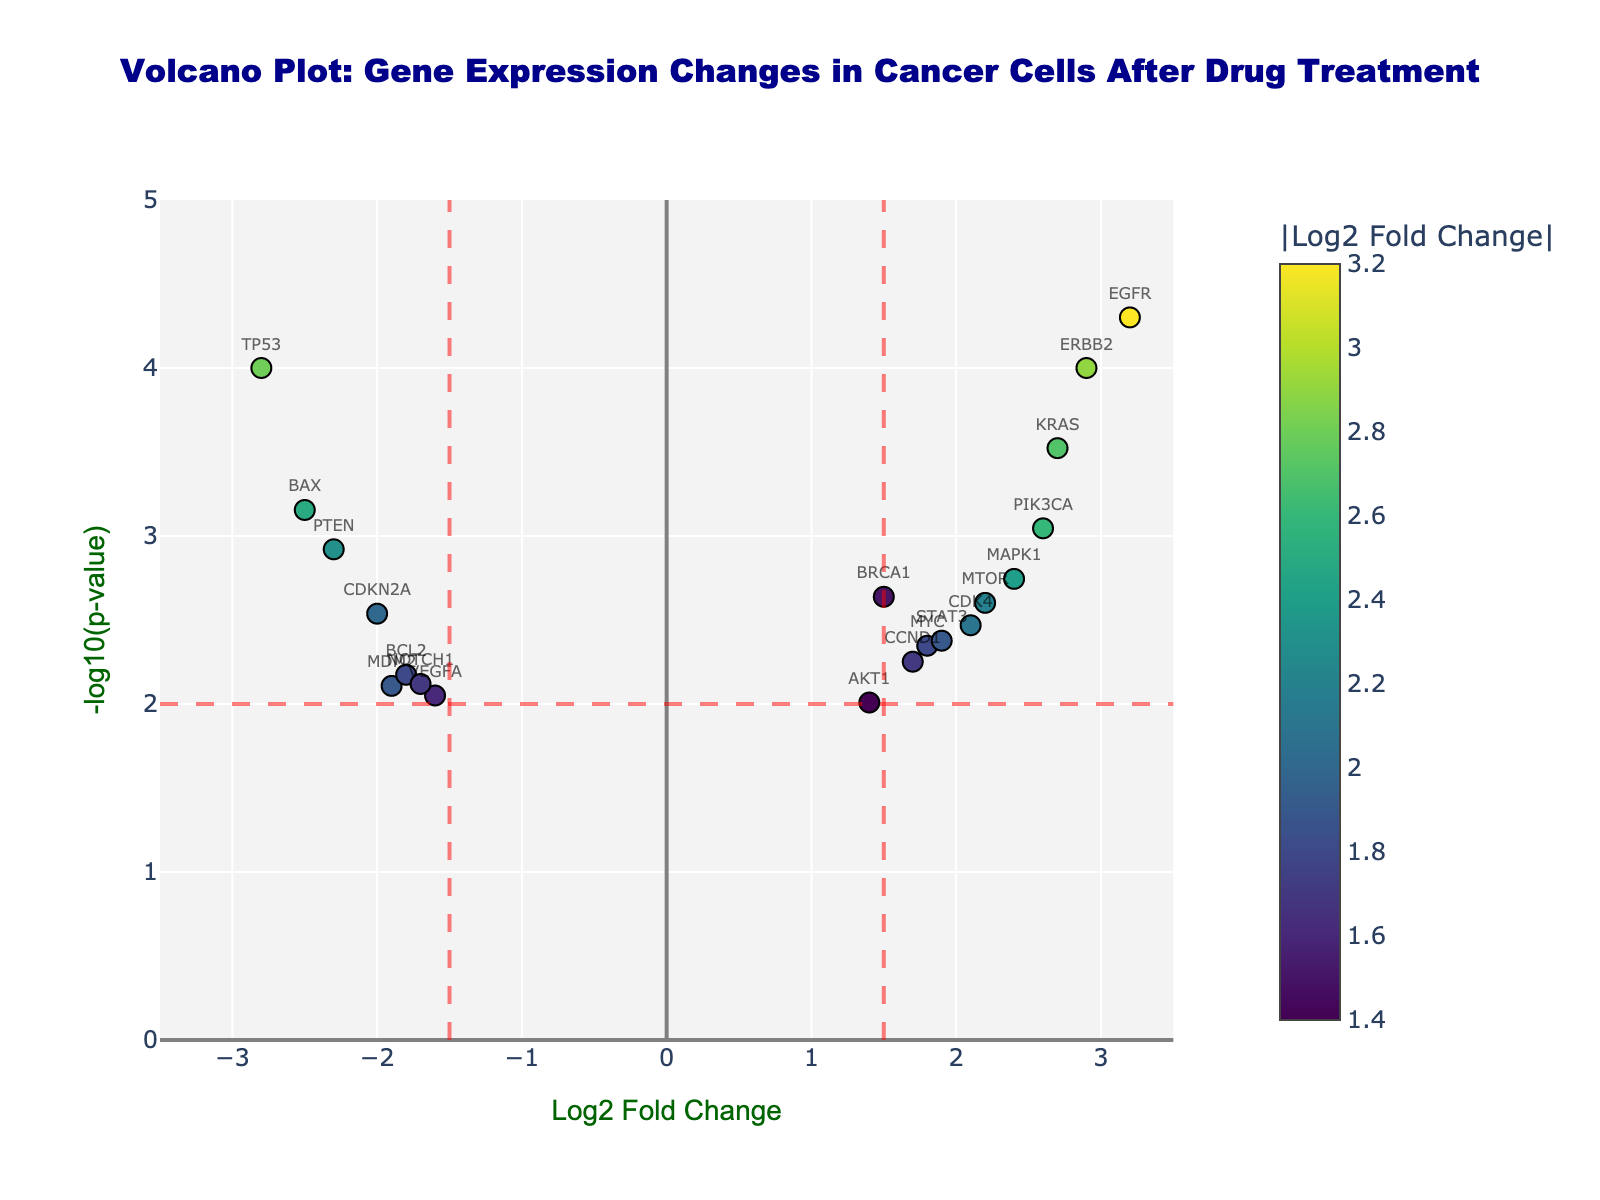What's the title of the figure? The title typically appears at the top of the figure. The given code shows the title as 'Volcano Plot: Gene Expression Changes in Cancer Cells After Drug Treatment'.
Answer: 'Volcano Plot: Gene Expression Changes in Cancer Cells After Drug Treatment' What's represented on the x-axis of the figure? The x-axis label is given in the code and shows 'Log2 Fold Change', which represents the fold change in gene expression measured on a log scale.
Answer: 'Log2 Fold Change' Which gene has the highest Log2 Fold Change value? By looking at the data and finding the highest Log2 Fold Change value, we see that EGFR has the highest value of 3.2.
Answer: EGFR How many genes have a significant fold change greater than 1.5 or less than -1.5? Count the genes with Log2 Fold Change values greater than 1.5 or less than -1.5. The genes are BRCA1, EGFR, KRAS, PTEN, MYC, ERBB2, BAX, CDK4, CCND1, MAPK1, PIK3CA, STAT3, MTOR. This totals to 13 genes.
Answer: 13 Which gene has the most significant p-value (lowest p-value)? The gene with the smallest p-value is determined by examining the list. EGFR has the lowest p-value of 0.00005.
Answer: EGFR If a gene has a Log2 Fold Change of -2.3 and a significant p-value, what is it? Cross-referencing the given data, a gene with a Log2 Fold Change of -2.3 and p-value of 0.0012 is PTEN.
Answer: PTEN What is the significance threshold for the p-value in the figure? The significance threshold for the p-value, as given in the code, is 0.01.
Answer: 0.01 Which upregulated gene has the closest fold change to 2.5? Looking at the data, MAPK1 has a Log2 Fold Change closest to 2.5 with a value of 2.4.
Answer: MAPK1 How many genes are downregulated with a Log2 Fold Change less than -2.0? Count the genes with Log2 Fold Change values less than -2.0. The genes are TP53, PTEN, BAX, and CDKN2A, totaling 4 genes.
Answer: 4 Which gene has a Log2 Fold Change of 2.9? According to the data, ERBB2 has a Log2 Fold Change of 2.9.
Answer: ERBB2 